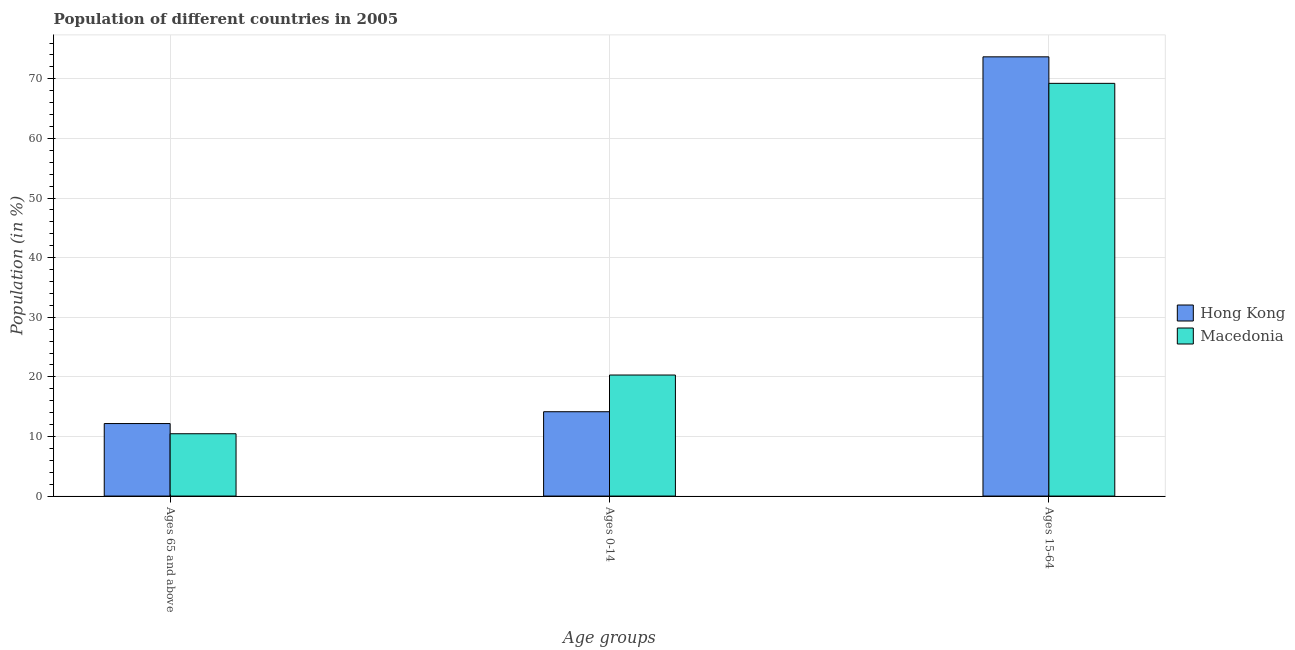How many different coloured bars are there?
Keep it short and to the point. 2. Are the number of bars per tick equal to the number of legend labels?
Offer a terse response. Yes. How many bars are there on the 3rd tick from the left?
Make the answer very short. 2. How many bars are there on the 1st tick from the right?
Your answer should be compact. 2. What is the label of the 3rd group of bars from the left?
Make the answer very short. Ages 15-64. What is the percentage of population within the age-group 15-64 in Hong Kong?
Your answer should be compact. 73.69. Across all countries, what is the maximum percentage of population within the age-group 15-64?
Give a very brief answer. 73.69. Across all countries, what is the minimum percentage of population within the age-group 15-64?
Keep it short and to the point. 69.24. In which country was the percentage of population within the age-group 0-14 maximum?
Provide a short and direct response. Macedonia. In which country was the percentage of population within the age-group 15-64 minimum?
Offer a terse response. Macedonia. What is the total percentage of population within the age-group of 65 and above in the graph?
Your response must be concise. 22.62. What is the difference between the percentage of population within the age-group 15-64 in Hong Kong and that in Macedonia?
Keep it short and to the point. 4.45. What is the difference between the percentage of population within the age-group 0-14 in Hong Kong and the percentage of population within the age-group of 65 and above in Macedonia?
Keep it short and to the point. 3.69. What is the average percentage of population within the age-group of 65 and above per country?
Your answer should be compact. 11.31. What is the difference between the percentage of population within the age-group 0-14 and percentage of population within the age-group of 65 and above in Macedonia?
Make the answer very short. 9.85. What is the ratio of the percentage of population within the age-group 0-14 in Macedonia to that in Hong Kong?
Your response must be concise. 1.44. What is the difference between the highest and the second highest percentage of population within the age-group 0-14?
Offer a very short reply. 6.16. What is the difference between the highest and the lowest percentage of population within the age-group 15-64?
Offer a terse response. 4.45. In how many countries, is the percentage of population within the age-group of 65 and above greater than the average percentage of population within the age-group of 65 and above taken over all countries?
Keep it short and to the point. 1. Is the sum of the percentage of population within the age-group 0-14 in Hong Kong and Macedonia greater than the maximum percentage of population within the age-group of 65 and above across all countries?
Your response must be concise. Yes. What does the 1st bar from the left in Ages 0-14 represents?
Provide a short and direct response. Hong Kong. What does the 2nd bar from the right in Ages 15-64 represents?
Offer a terse response. Hong Kong. Is it the case that in every country, the sum of the percentage of population within the age-group of 65 and above and percentage of population within the age-group 0-14 is greater than the percentage of population within the age-group 15-64?
Ensure brevity in your answer.  No. Does the graph contain grids?
Make the answer very short. Yes. Where does the legend appear in the graph?
Make the answer very short. Center right. How many legend labels are there?
Ensure brevity in your answer.  2. What is the title of the graph?
Make the answer very short. Population of different countries in 2005. What is the label or title of the X-axis?
Your response must be concise. Age groups. What is the Population (in %) of Hong Kong in Ages 65 and above?
Offer a terse response. 12.16. What is the Population (in %) of Macedonia in Ages 65 and above?
Keep it short and to the point. 10.46. What is the Population (in %) in Hong Kong in Ages 0-14?
Give a very brief answer. 14.15. What is the Population (in %) in Macedonia in Ages 0-14?
Your answer should be very brief. 20.31. What is the Population (in %) in Hong Kong in Ages 15-64?
Ensure brevity in your answer.  73.69. What is the Population (in %) in Macedonia in Ages 15-64?
Offer a very short reply. 69.24. Across all Age groups, what is the maximum Population (in %) in Hong Kong?
Your response must be concise. 73.69. Across all Age groups, what is the maximum Population (in %) of Macedonia?
Offer a terse response. 69.24. Across all Age groups, what is the minimum Population (in %) in Hong Kong?
Your answer should be very brief. 12.16. Across all Age groups, what is the minimum Population (in %) of Macedonia?
Keep it short and to the point. 10.46. What is the total Population (in %) of Macedonia in the graph?
Give a very brief answer. 100. What is the difference between the Population (in %) of Hong Kong in Ages 65 and above and that in Ages 0-14?
Offer a terse response. -1.99. What is the difference between the Population (in %) in Macedonia in Ages 65 and above and that in Ages 0-14?
Provide a succinct answer. -9.85. What is the difference between the Population (in %) of Hong Kong in Ages 65 and above and that in Ages 15-64?
Ensure brevity in your answer.  -61.52. What is the difference between the Population (in %) of Macedonia in Ages 65 and above and that in Ages 15-64?
Provide a succinct answer. -58.78. What is the difference between the Population (in %) in Hong Kong in Ages 0-14 and that in Ages 15-64?
Your answer should be compact. -59.54. What is the difference between the Population (in %) of Macedonia in Ages 0-14 and that in Ages 15-64?
Your response must be concise. -48.93. What is the difference between the Population (in %) of Hong Kong in Ages 65 and above and the Population (in %) of Macedonia in Ages 0-14?
Ensure brevity in your answer.  -8.14. What is the difference between the Population (in %) of Hong Kong in Ages 65 and above and the Population (in %) of Macedonia in Ages 15-64?
Provide a succinct answer. -57.07. What is the difference between the Population (in %) in Hong Kong in Ages 0-14 and the Population (in %) in Macedonia in Ages 15-64?
Make the answer very short. -55.09. What is the average Population (in %) in Hong Kong per Age groups?
Ensure brevity in your answer.  33.33. What is the average Population (in %) of Macedonia per Age groups?
Keep it short and to the point. 33.33. What is the difference between the Population (in %) in Hong Kong and Population (in %) in Macedonia in Ages 65 and above?
Keep it short and to the point. 1.71. What is the difference between the Population (in %) of Hong Kong and Population (in %) of Macedonia in Ages 0-14?
Give a very brief answer. -6.16. What is the difference between the Population (in %) of Hong Kong and Population (in %) of Macedonia in Ages 15-64?
Offer a terse response. 4.45. What is the ratio of the Population (in %) in Hong Kong in Ages 65 and above to that in Ages 0-14?
Offer a terse response. 0.86. What is the ratio of the Population (in %) in Macedonia in Ages 65 and above to that in Ages 0-14?
Provide a succinct answer. 0.51. What is the ratio of the Population (in %) of Hong Kong in Ages 65 and above to that in Ages 15-64?
Offer a terse response. 0.17. What is the ratio of the Population (in %) in Macedonia in Ages 65 and above to that in Ages 15-64?
Your response must be concise. 0.15. What is the ratio of the Population (in %) of Hong Kong in Ages 0-14 to that in Ages 15-64?
Offer a terse response. 0.19. What is the ratio of the Population (in %) in Macedonia in Ages 0-14 to that in Ages 15-64?
Keep it short and to the point. 0.29. What is the difference between the highest and the second highest Population (in %) in Hong Kong?
Provide a succinct answer. 59.54. What is the difference between the highest and the second highest Population (in %) in Macedonia?
Provide a short and direct response. 48.93. What is the difference between the highest and the lowest Population (in %) of Hong Kong?
Your answer should be compact. 61.52. What is the difference between the highest and the lowest Population (in %) in Macedonia?
Give a very brief answer. 58.78. 